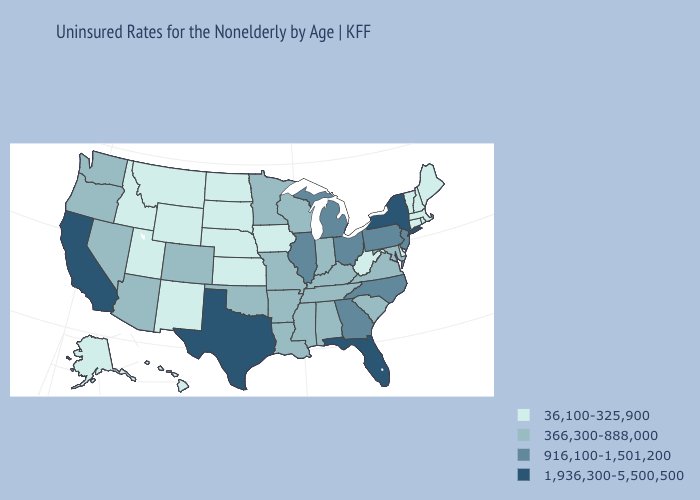Does Idaho have the highest value in the West?
Concise answer only. No. Name the states that have a value in the range 916,100-1,501,200?
Give a very brief answer. Georgia, Illinois, Michigan, New Jersey, North Carolina, Ohio, Pennsylvania. What is the highest value in the USA?
Keep it brief. 1,936,300-5,500,500. What is the value of New Hampshire?
Short answer required. 36,100-325,900. Name the states that have a value in the range 1,936,300-5,500,500?
Concise answer only. California, Florida, New York, Texas. What is the highest value in states that border Ohio?
Write a very short answer. 916,100-1,501,200. What is the value of Washington?
Keep it brief. 366,300-888,000. Does Texas have the highest value in the South?
Keep it brief. Yes. Name the states that have a value in the range 36,100-325,900?
Be succinct. Alaska, Connecticut, Delaware, Hawaii, Idaho, Iowa, Kansas, Maine, Massachusetts, Montana, Nebraska, New Hampshire, New Mexico, North Dakota, Rhode Island, South Dakota, Utah, Vermont, West Virginia, Wyoming. Does the map have missing data?
Quick response, please. No. What is the value of Utah?
Keep it brief. 36,100-325,900. Name the states that have a value in the range 36,100-325,900?
Quick response, please. Alaska, Connecticut, Delaware, Hawaii, Idaho, Iowa, Kansas, Maine, Massachusetts, Montana, Nebraska, New Hampshire, New Mexico, North Dakota, Rhode Island, South Dakota, Utah, Vermont, West Virginia, Wyoming. What is the value of Arizona?
Answer briefly. 366,300-888,000. Is the legend a continuous bar?
Give a very brief answer. No. Name the states that have a value in the range 1,936,300-5,500,500?
Short answer required. California, Florida, New York, Texas. 